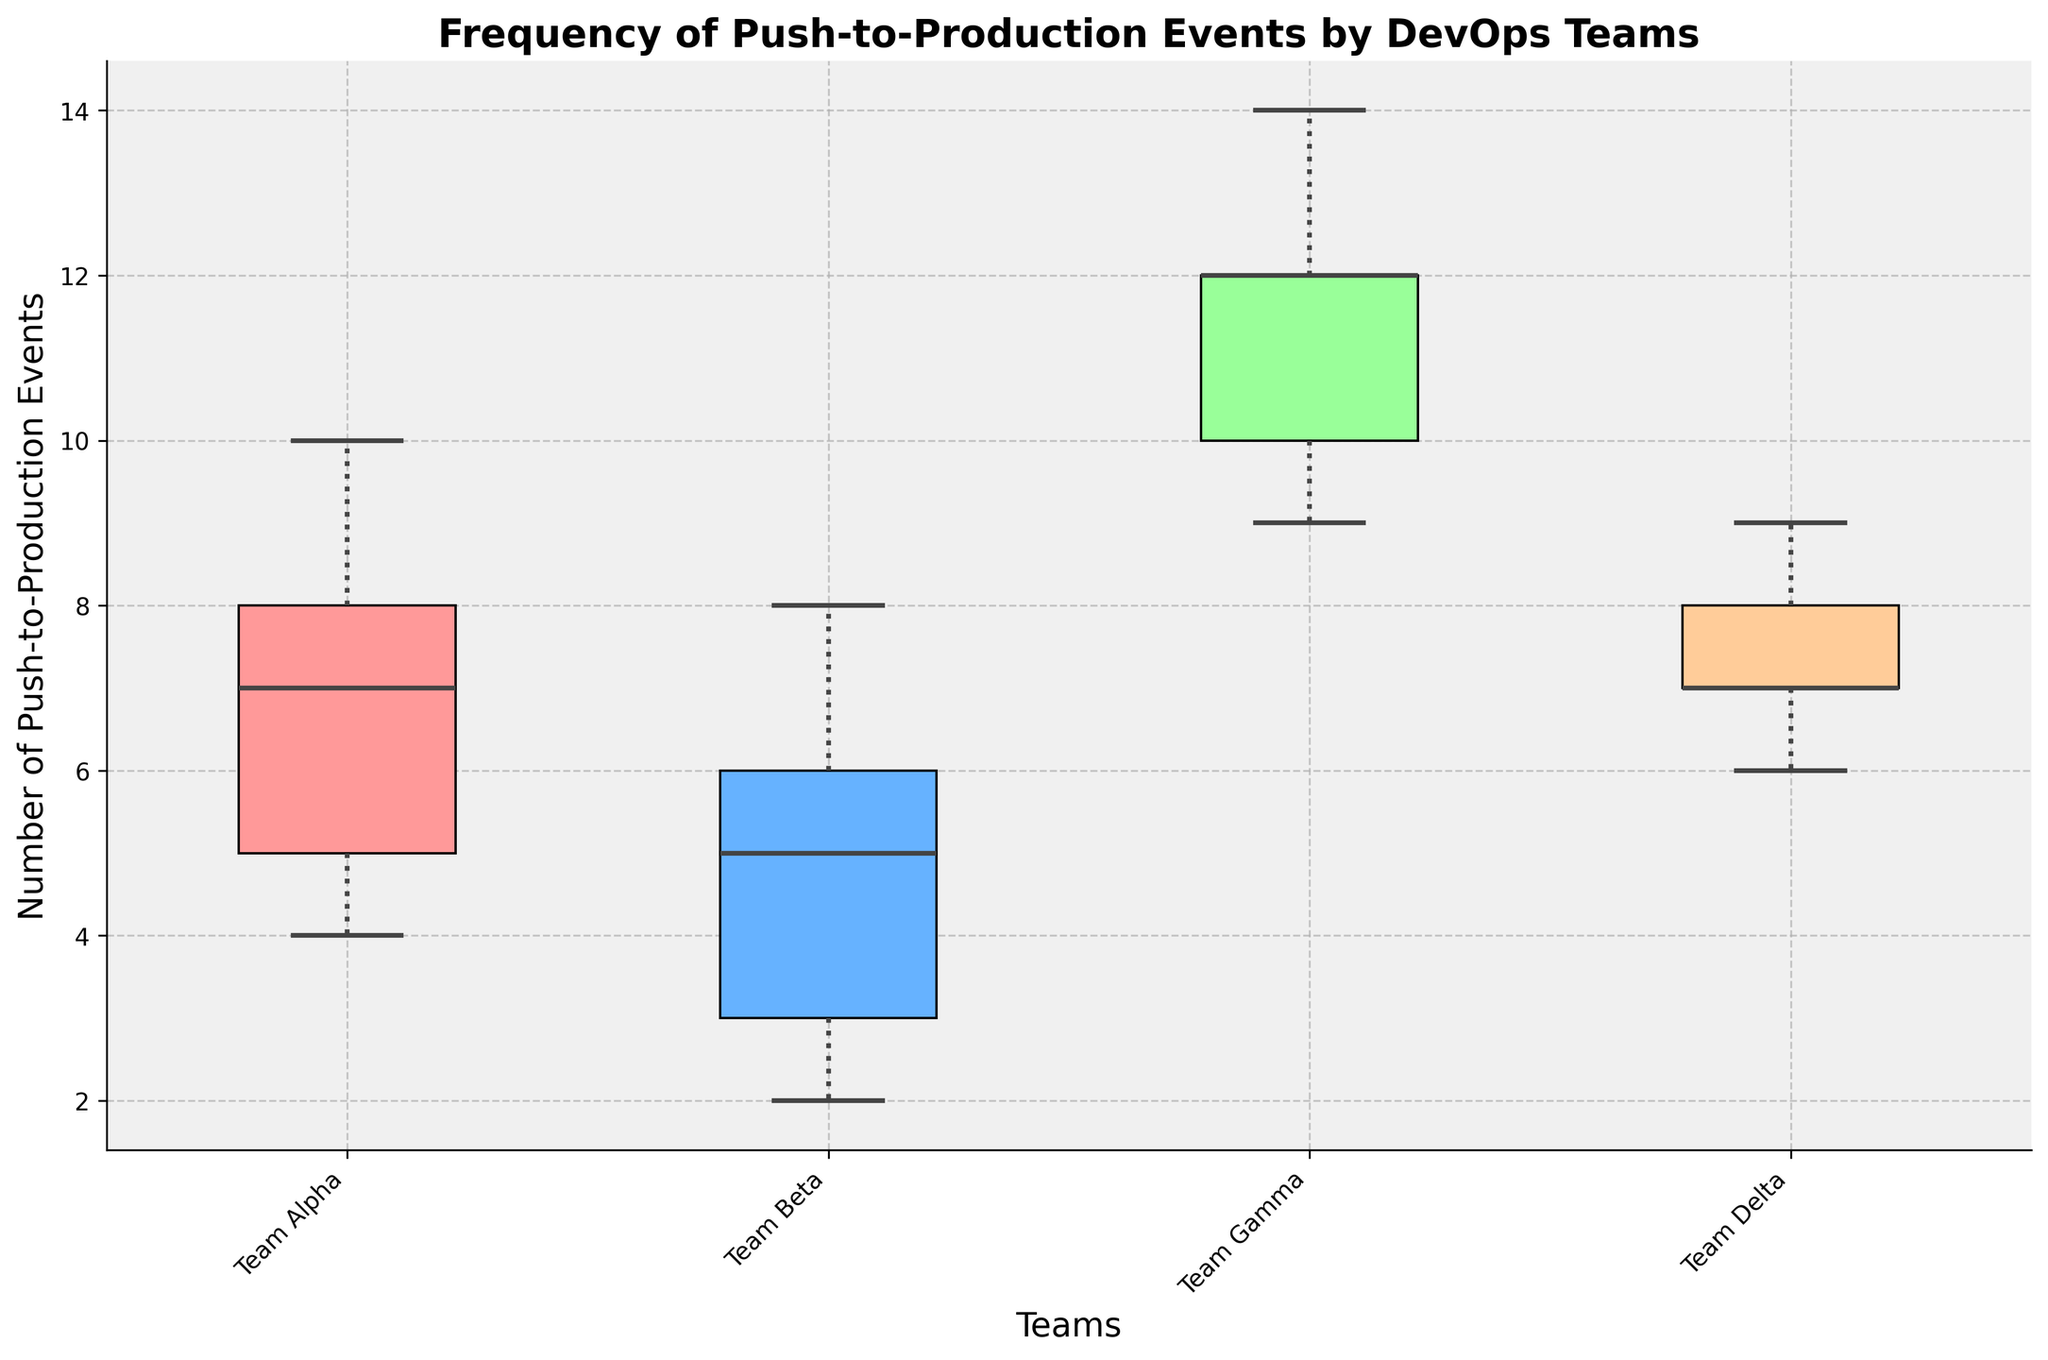What is the title of the figure? The title is the text at the top of the figure which provides an overview of what the figure represents. In this case, it details the frequency of push-to-production events in DevOps teams.
Answer: Frequency of Push-to-Production Events by DevOps Teams What teams are displayed on the x-axis? The teams displayed on the x-axis can be identified by looking at the labels beneath the box plots.
Answer: Team Alpha, Team Beta, Team Gamma, Team Delta Which team shows the highest median number of push-to-production events? The median is represented by the line inside each box. By comparing the positions of these lines, we can identify the team with the highest median.
Answer: Team Gamma How many data points are there for Team Alpha in January? Each data point is indicated by the small circles around the box plots. By counting these points for Team Alpha's January box plot, we can determine the number of events.
Answer: 3 Which team has the least variability in push-to-production events? Variability can be assessed by the length of the box and whiskers. The shorter these elements, the less variability.
Answer: Team Delta What is the range of push-to-production events for Team Beta in March? The range is the difference between the maximum and minimum values. For Team Beta in March, this is the distance from the top whisker to the bottom whisker.
Answer: 3 What is the interquartile range (IQR) for Team Gamma? The IQR can be obtained by subtracting the first quartile (bottom of the box) from the third quartile (top of the box). Team Gamma's box plot provides these values visually.
Answer: 3 Which team has more consistent push-to-production events: Team Alpha or Team Delta? Consistency can be judged by how tight the whiskers and box are. Comparing the sizes of these elements can indicate which team has more consistent events.
Answer: Team Delta Which team has at least one outlier in their data? Outliers are represented by points that fall outside the whiskers. Observing any points outside the whiskers indicates the presence of an outlier.
Answer: None 